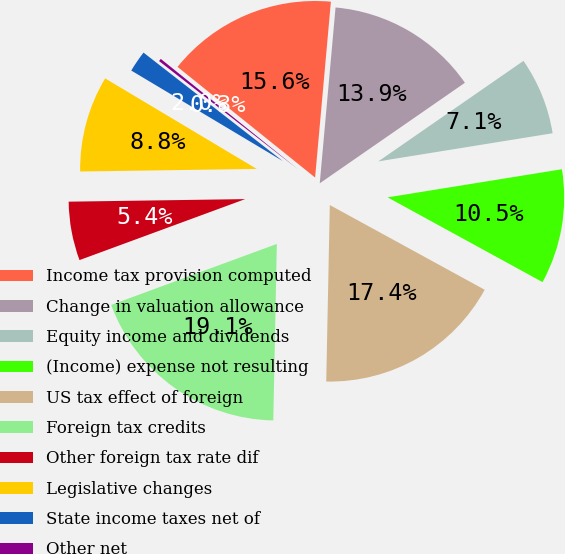<chart> <loc_0><loc_0><loc_500><loc_500><pie_chart><fcel>Income tax provision computed<fcel>Change in valuation allowance<fcel>Equity income and dividends<fcel>(Income) expense not resulting<fcel>US tax effect of foreign<fcel>Foreign tax credits<fcel>Other foreign tax rate dif<fcel>Legislative changes<fcel>State income taxes net of<fcel>Other net<nl><fcel>15.64%<fcel>13.93%<fcel>7.09%<fcel>10.51%<fcel>17.35%<fcel>19.06%<fcel>5.38%<fcel>8.8%<fcel>1.96%<fcel>0.25%<nl></chart> 